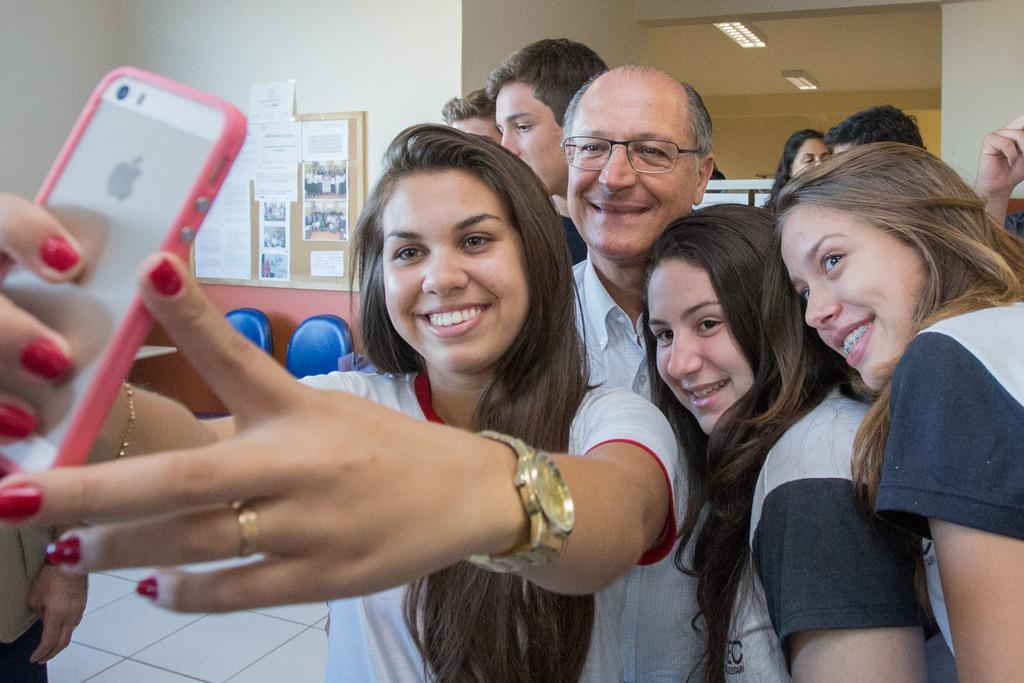Describe this image in one or two sentences. a person is taking selfie in the phone. there are many people behind her. at the left there is a notice board, many papers are sticked to it. 